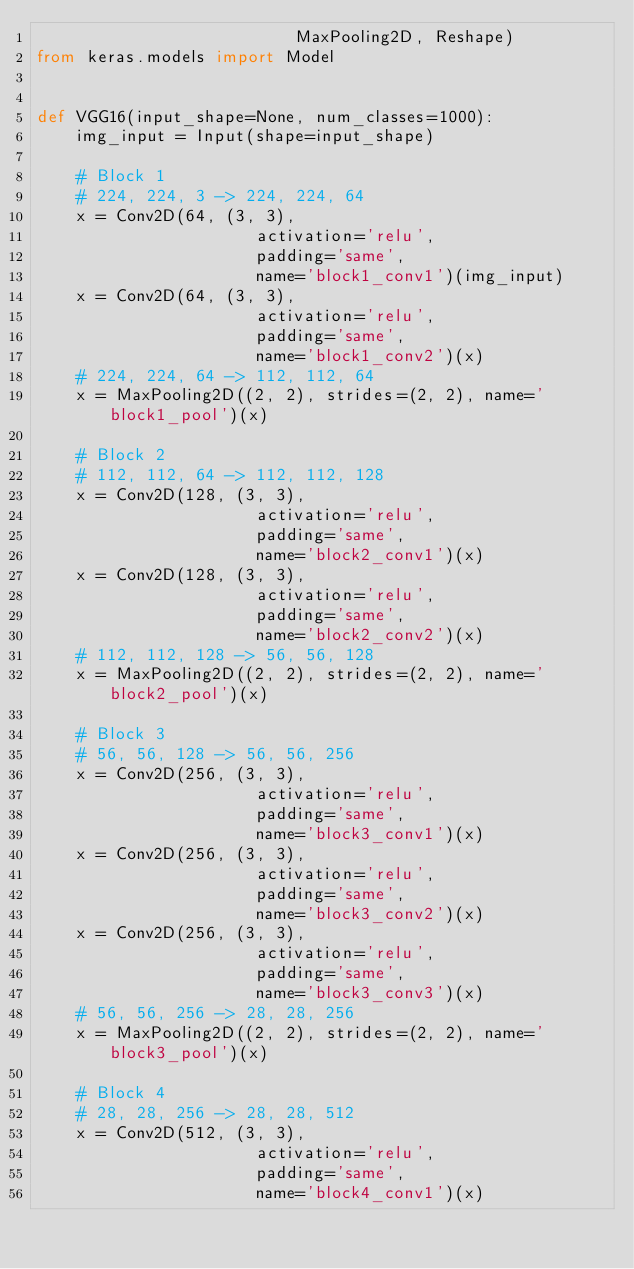<code> <loc_0><loc_0><loc_500><loc_500><_Python_>                          MaxPooling2D, Reshape)
from keras.models import Model


def VGG16(input_shape=None, num_classes=1000):
    img_input = Input(shape=input_shape)

    # Block 1
    # 224, 224, 3 -> 224, 224, 64
    x = Conv2D(64, (3, 3),
                      activation='relu',
                      padding='same',
                      name='block1_conv1')(img_input)
    x = Conv2D(64, (3, 3),
                      activation='relu',
                      padding='same',
                      name='block1_conv2')(x)
    # 224, 224, 64 -> 112, 112, 64
    x = MaxPooling2D((2, 2), strides=(2, 2), name='block1_pool')(x)

    # Block 2
    # 112, 112, 64 -> 112, 112, 128
    x = Conv2D(128, (3, 3),
                      activation='relu',
                      padding='same',
                      name='block2_conv1')(x)
    x = Conv2D(128, (3, 3),
                      activation='relu',
                      padding='same',
                      name='block2_conv2')(x)
    # 112, 112, 128 -> 56, 56, 128
    x = MaxPooling2D((2, 2), strides=(2, 2), name='block2_pool')(x)

    # Block 3
    # 56, 56, 128 -> 56, 56, 256
    x = Conv2D(256, (3, 3),
                      activation='relu',
                      padding='same',
                      name='block3_conv1')(x)
    x = Conv2D(256, (3, 3),
                      activation='relu',
                      padding='same',
                      name='block3_conv2')(x)
    x = Conv2D(256, (3, 3),
                      activation='relu',
                      padding='same',
                      name='block3_conv3')(x)
    # 56, 56, 256 -> 28, 28, 256
    x = MaxPooling2D((2, 2), strides=(2, 2), name='block3_pool')(x)

    # Block 4
    # 28, 28, 256 -> 28, 28, 512
    x = Conv2D(512, (3, 3),
                      activation='relu',
                      padding='same',
                      name='block4_conv1')(x)</code> 